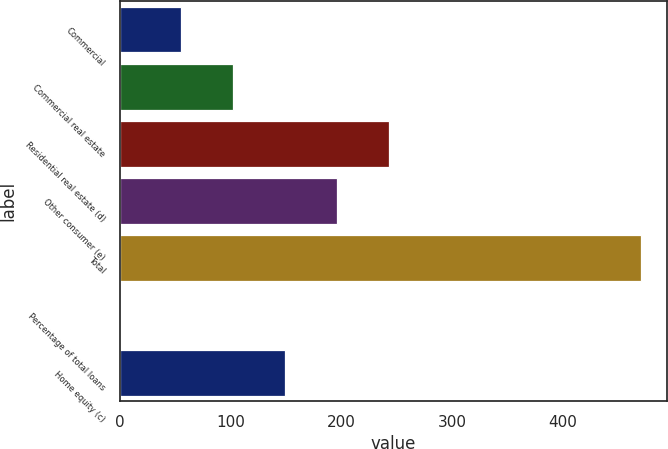Convert chart. <chart><loc_0><loc_0><loc_500><loc_500><bar_chart><fcel>Commercial<fcel>Commercial real estate<fcel>Residential real estate (d)<fcel>Other consumer (e)<fcel>Total<fcel>Percentage of total loans<fcel>Home equity (c)<nl><fcel>55<fcel>102.08<fcel>243.31<fcel>196.24<fcel>471<fcel>0.25<fcel>149.16<nl></chart> 